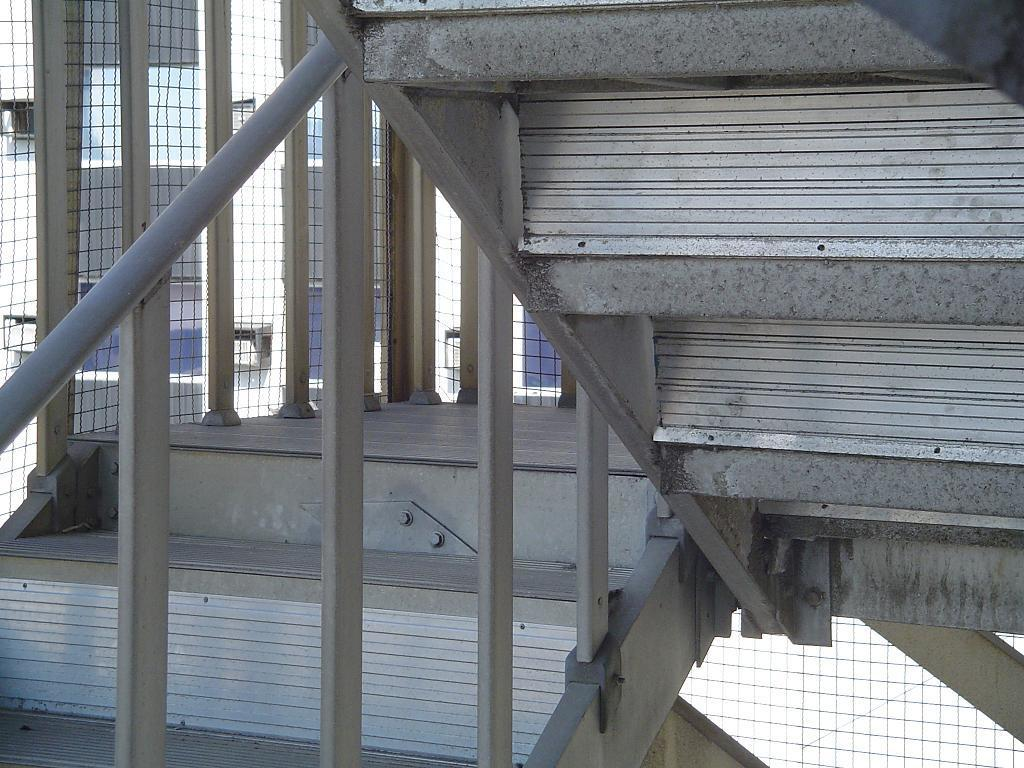What type of structure can be seen in the image? There are stairs in the image. What is located near the stairs? There is a fence in the image. What can be seen in the distance in the image? There are buildings in the background of the image. What type of leather is used to make the parcel visible in the image? There is no parcel visible in the image, and therefore no leather can be associated with it. 